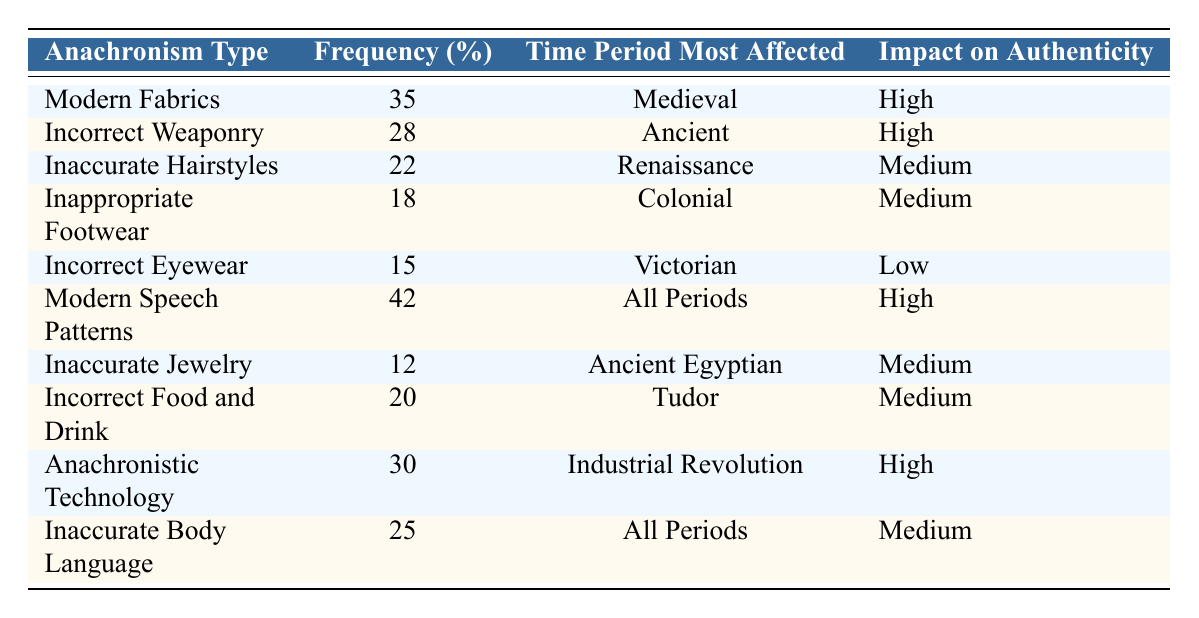What is the frequency percentage of Modern Fabrics anachronism? The table lists the frequency percentage of Modern Fabrics as 35%.
Answer: 35% Which time period is most affected by Incorrect Weaponry? According to the table, Incorrect Weaponry is most affected during the Ancient time period.
Answer: Ancient How many anachronism types have a high impact on authenticity? The table shows that four anachronism types (Modern Fabrics, Incorrect Weaponry, Modern Speech Patterns, and Anachronistic Technology) have a high impact on authenticity.
Answer: Four What is the average frequency percentage of anachronisms that impact authenticity with Medium effect? First, identify the anachronisms with Medium impact: Inaccurate Hairstyles (22%), Inappropriate Footwear (18%), Inaccurate Jewelry (12%), Incorrect Food and Drink (20%), and Inaccurate Body Language (25%). Their total is 22 + 18 + 12 + 20 + 25 = 97%. Then, divide by 5 (the number of entries) to calculate the average: 97% / 5 = 19.4%.
Answer: 19.4% Is Correct Eyewear a common anachronism found in reenactments? The table indicates Incorrect Eyewear is present, but with a frequency of only 15%, which may suggest less common usage. Therefore, it is not considered common.
Answer: No What is the difference in frequency percentage between Modern Speech Patterns and Inaccurate Jewelry? Modern Speech Patterns frequents at 42% and Inaccurate Jewelry at 12%. The difference is 42% - 12% = 30%.
Answer: 30% Which anachronism type has the lowest impact on authenticity and what is its frequency percentage? The table shows that Incorrect Eyewear has the lowest impact on authenticity marked as Low, with a frequency percentage of 15%.
Answer: 15% How many types of anachronisms predominantly affect the Medieval and Industrial Revolution time periods? Modern Fabrics (Medieval) and Anachronistic Technology (Industrial Revolution) show that there are two types of anachronisms affecting these specific time periods.
Answer: Two 